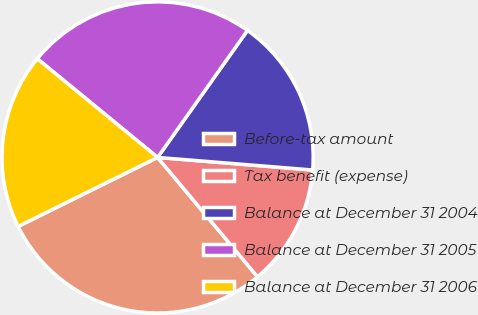<chart> <loc_0><loc_0><loc_500><loc_500><pie_chart><fcel>Before-tax amount<fcel>Tax benefit (expense)<fcel>Balance at December 31 2004<fcel>Balance at December 31 2005<fcel>Balance at December 31 2006<nl><fcel>28.78%<fcel>12.62%<fcel>16.49%<fcel>23.87%<fcel>18.25%<nl></chart> 